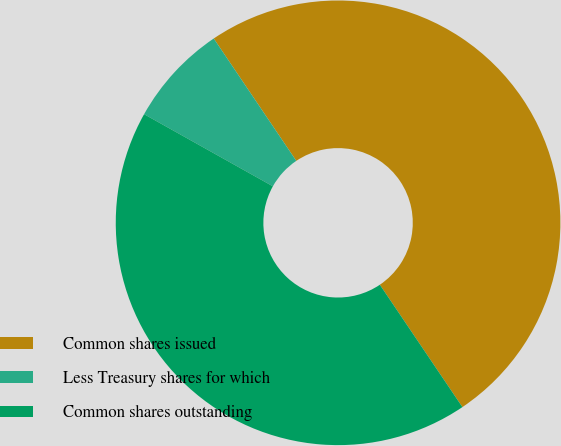Convert chart. <chart><loc_0><loc_0><loc_500><loc_500><pie_chart><fcel>Common shares issued<fcel>Less Treasury shares for which<fcel>Common shares outstanding<nl><fcel>50.0%<fcel>7.43%<fcel>42.57%<nl></chart> 